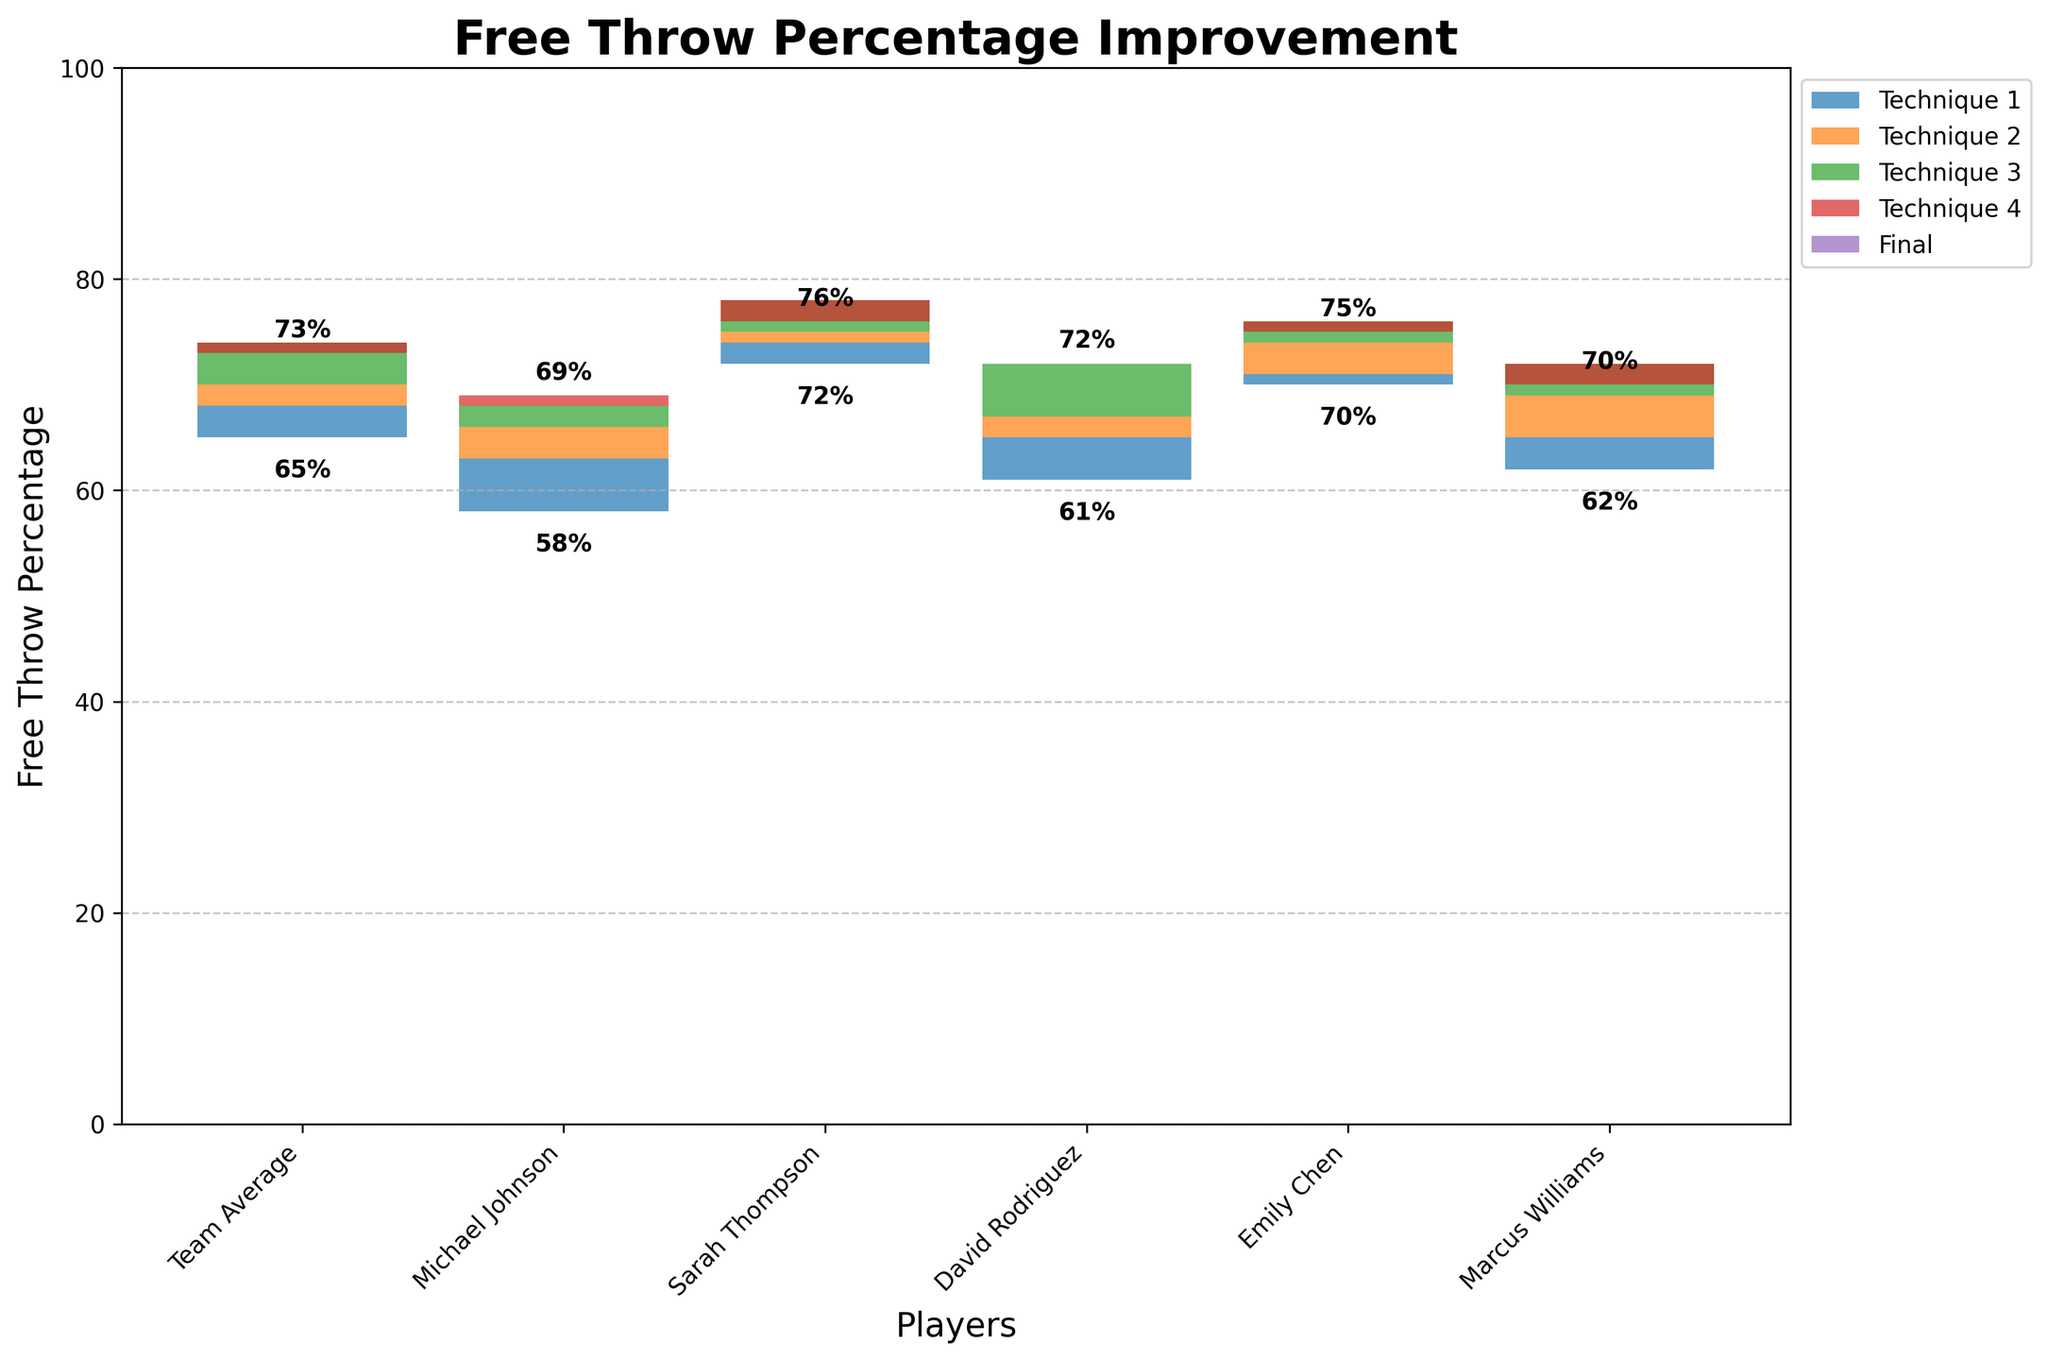What's the title of the chart? The title of the chart is found at the top and usually summarizes the main focus of the data presented.
Answer: Free Throw Percentage Improvement Which techniques resulted in a positive improvement on the team average? Looking at the Team Average and checking the increases marked with a "+" sign. Techniques 1 (+3%), 2 (+2%), and 3 (+4%) all show improvements.
Answer: Technique 1, Technique 2, Technique 3 How many players showed an overall improvement in their free throw percentage? Subtract the initial percentage from the final percentage for each player, and count those that are greater than zero. Michael Johnson: 69-58 = 11; Sarah Thompson: 76-72 = 4; David Rodriguez: 72-61 = 11; Emily Chen: 75-70 = 5; Marcus Williams: 70-62 = 8. All players showed improvement.
Answer: All five players Who had the maximum improvement from the initial percentage to the final percentage? Calculate the improvement for each player. Michael Johnson: 11%, Sarah Thompson: 4%, David Rodriguez: 11%, Emily Chen: 5%, Marcus Williams: 8%. Michael Johnson and David Rodriguez both had the highest improvement of 11%.
Answer: Michael Johnson, David Rodriguez Which technique had the largest positive effect on Emily Chen’s performance? Identify the highest positive value for Emily Chen. Her improvements are Technique 1: +1%, Technique 2: +3%, Technique 3: +2%, Technique 4: -1%. The largest value is Technique 2 at +3%.
Answer: Technique 2 What is the combined percentage increase for Marcus Williams after using Techniques 1, 2, and 3? Add the percentage increases from each of these techniques for Marcus: Technique 1: +3%, Technique 2: +4%, Technique 3: +3%. 3 + 4 + 3 = 10%.
Answer: 10% If Technique 4 had not been applied, what would be the final free throw percentage for Sarah Thompson? Add Sarah Thompson's initial percentage and the effects of Techniques 1, 2, and 3, omitting Technique 4. Initial: 72%, Technique 1: +2%, Technique 2: +1%, Technique 3: +3%. 72 + 2 + 1 + 3 = 78%.
Answer: 78% Which player improved the least in free throw percentage? Calculate the difference between the initial and final percentages for each player. Michael Johnson: 11%, Sarah Thompson: 4%, David Rodriguez: 11%, Emily Chen: 5%, Marcus Williams: 8%. The smallest improvement is Sarah Thompson with 4%.
Answer: Sarah Thompson How many players had a decrease in their performance with Technique 4? Check the percentage change for Technique 4 for each player. Michael Johnson: +1%, Sarah Thompson: -2%, David Rodriguez: 0%, Emily Chen: -1%, Marcus Williams: -2%. Three players had a decrease.
Answer: Three players 